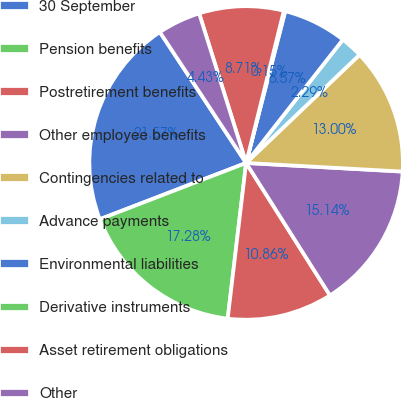Convert chart to OTSL. <chart><loc_0><loc_0><loc_500><loc_500><pie_chart><fcel>30 September<fcel>Pension benefits<fcel>Postretirement benefits<fcel>Other employee benefits<fcel>Contingencies related to<fcel>Advance payments<fcel>Environmental liabilities<fcel>Derivative instruments<fcel>Asset retirement obligations<fcel>Other<nl><fcel>21.57%<fcel>17.28%<fcel>10.86%<fcel>15.14%<fcel>13.0%<fcel>2.29%<fcel>6.57%<fcel>0.15%<fcel>8.71%<fcel>4.43%<nl></chart> 